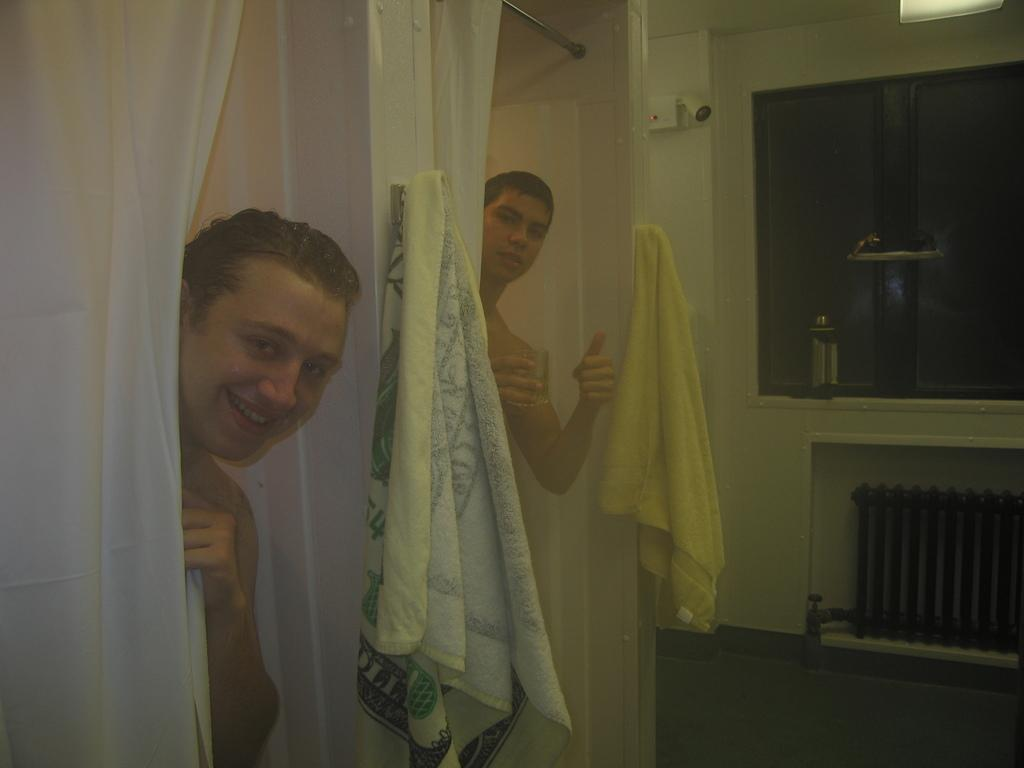What can be seen in the image? There are men standing in the image. Where are the men standing? The men are standing on the floor. What can be seen hanging on the walls? Towels are hanging on hooks. What type of window treatment is present in the image? There are curtains in the image. What is visible through the windows? Windows are visible in the image. What type of security device is present in the image? A CCTV camera is present in the image. What is the surface that the men are standing on? The floor is visible in the image. What type of hydrant is present in the image? There is no hydrant present in the image. How does the CCTV camera kick the ball in the image? The CCTV camera does not kick a ball in the image; it is a stationary security device. 